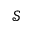Convert formula to latex. <formula><loc_0><loc_0><loc_500><loc_500>\mathcal { S }</formula> 